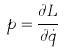<formula> <loc_0><loc_0><loc_500><loc_500>p = \frac { \partial L } { \partial \dot { q } }</formula> 